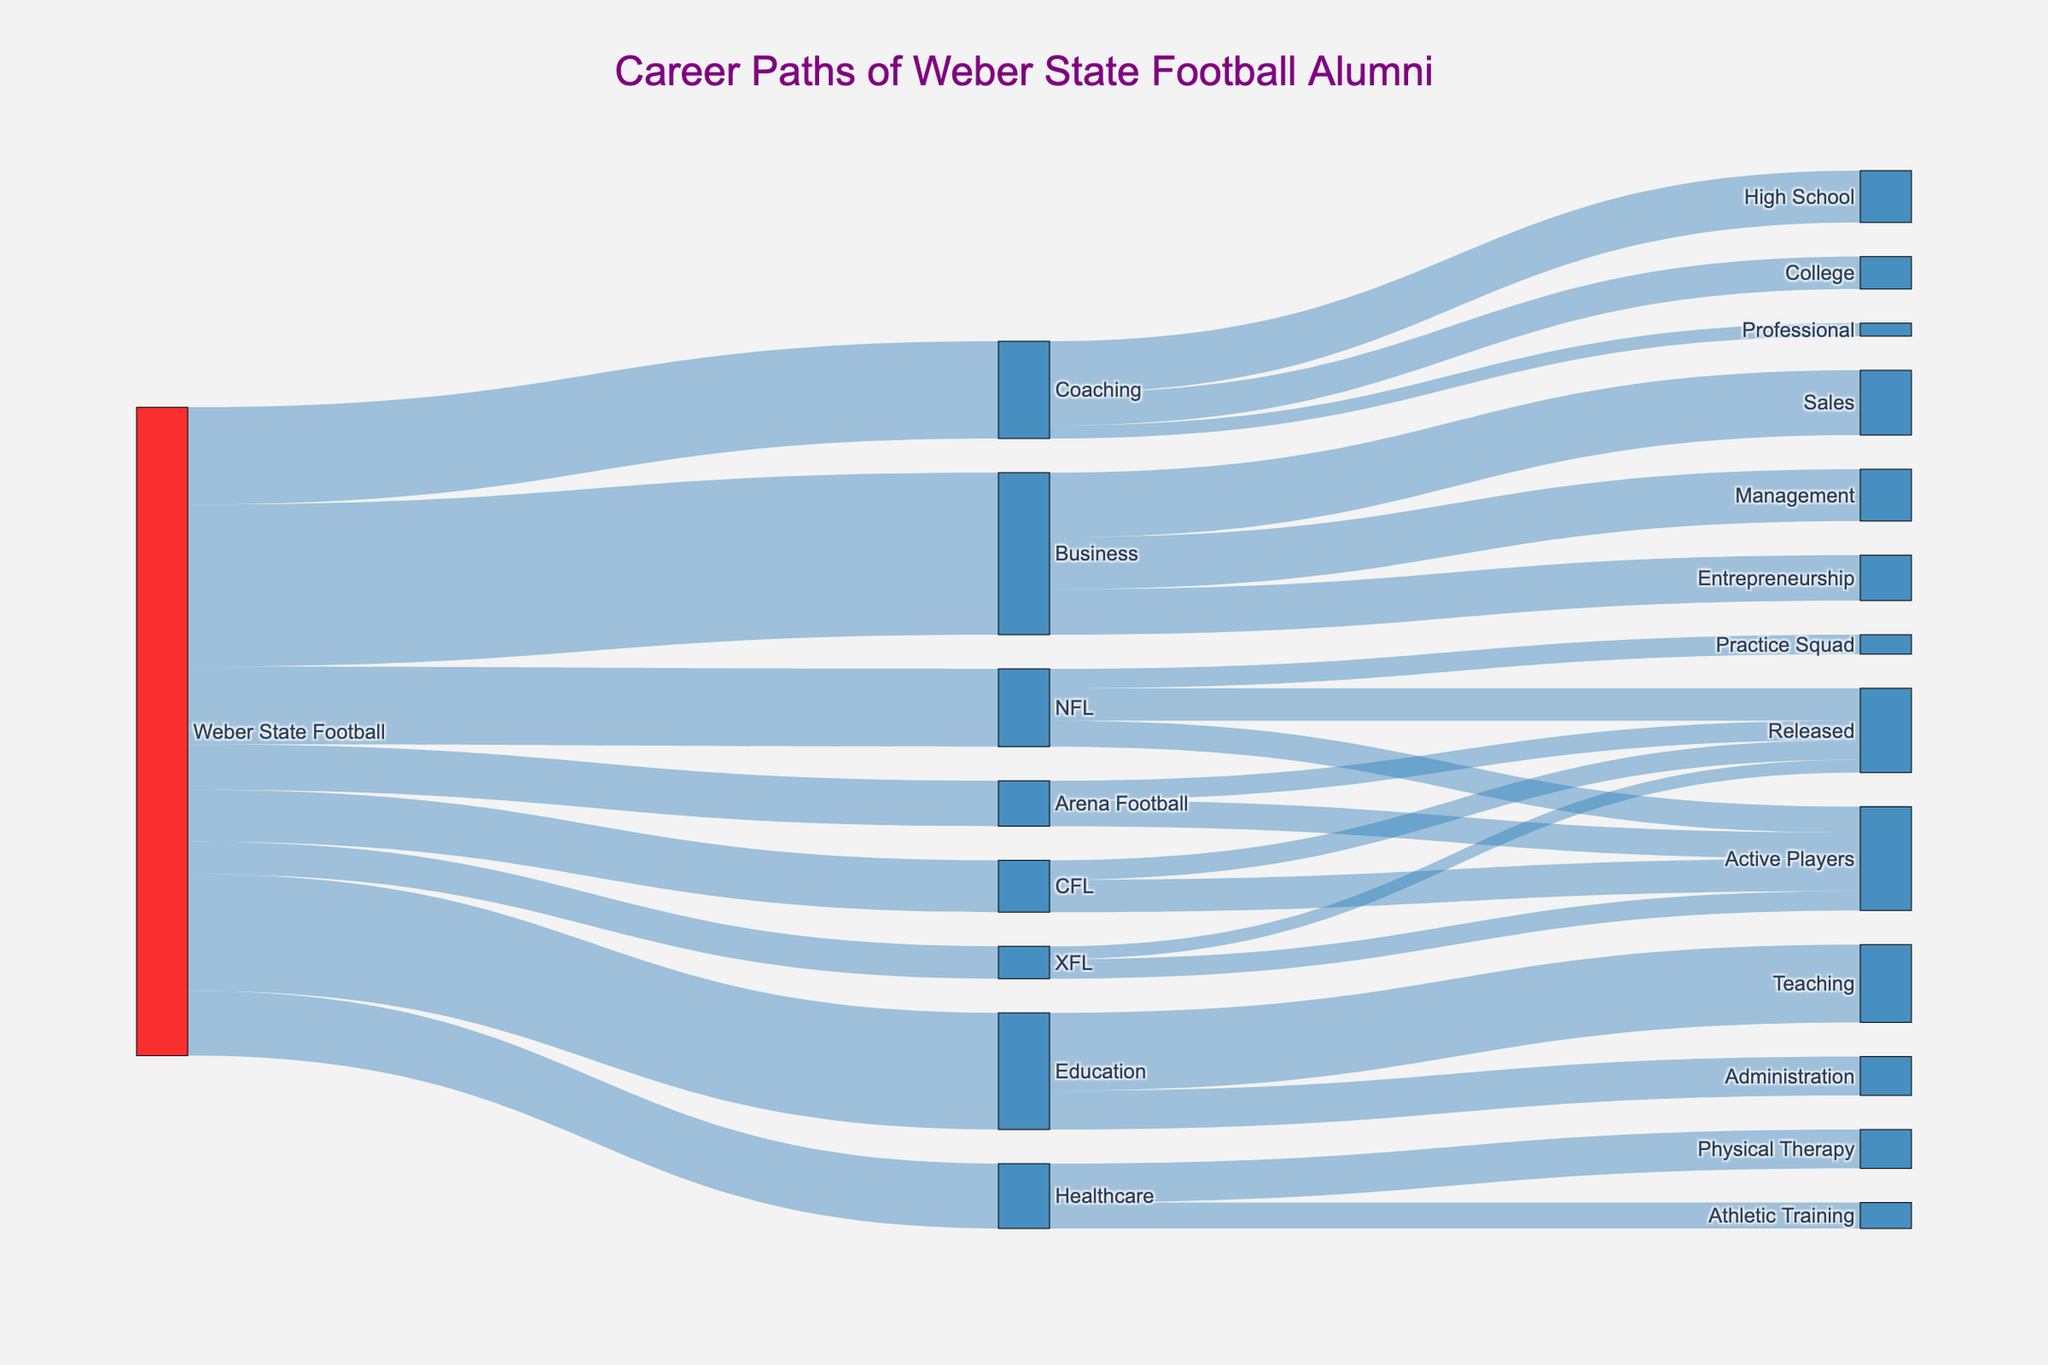What is the title of the Sankey Diagram? The title of a figure is usually located at the top and provides a brief description of what the figure is about. In this diagram, it clearly states the nature and focus of the data being visualized.
Answer: Career Paths of Weber State Football Alumni How many Weber State football alumni went into the NFL? Locate the flow from "Weber State Football" to "NFL" and check the value associated with this link. It represents the number of alumni who pursued a career in the NFL.
Answer: 12 What is the total number of Weber State football alumni who pursued careers in professional football leagues (NFL, CFL, XFL, Arena Football)? Sum the values of the flows from "Weber State Football" to all professional football leagues. Add 12 (NFL) + 8 (CFL) + 5 (XFL) + 7 (Arena Football).
Answer: 32 Among the professional leagues, which league has the highest number of active players and how many are there? Review the nodes representing active players for each league and identify the highest value. The respective flows are from NFL to Active Players (4), CFL to Active Players (5), XFL to Active Players (3), and Arena Football to Active Players (4).
Answer: CFL, 5 How many alumni moved into careers outside of professional sports (Business, Education, Healthcare)? Sum the values of the flows from "Weber State Football" to Business (25), Education (18), and Healthcare (10).
Answer: 53 Which career path has the highest number of alumni and how many are there? Examine all the secondary paths originating from "Weber State Football" and identify the path with the highest value.
Answer: Business, 25 What percentage of alumni who pursued Coaching ended up in high school coaching? Identify the total number of alumni in Coaching (15) and the number in High School Coaching (8). Calculate the percentage as (8/15)*100.
Answer: 53.3% Compare the number of alumni who pursued Entrepreneurship with those in Administration in Education. Which is higher and by how much? Check the values for Entrepreneurship (7) in Business and Administration (6) in Education, then find the difference.
Answer: Entrepreneurship is higher by 1 What is the total number of alumni who became either Physical Therapists or Athletic Trainers? Sum the values of the flows to Physical Therapy (6) and Athletic Training (4) under Healthcare.
Answer: 10 How many alumni in total pursued a career in Coaching? Identify the value associated with the flow from "Weber State Football" to Coaching.
Answer: 15 